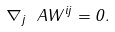<formula> <loc_0><loc_0><loc_500><loc_500>\nabla _ { j } \ A W ^ { i j } = 0 .</formula> 